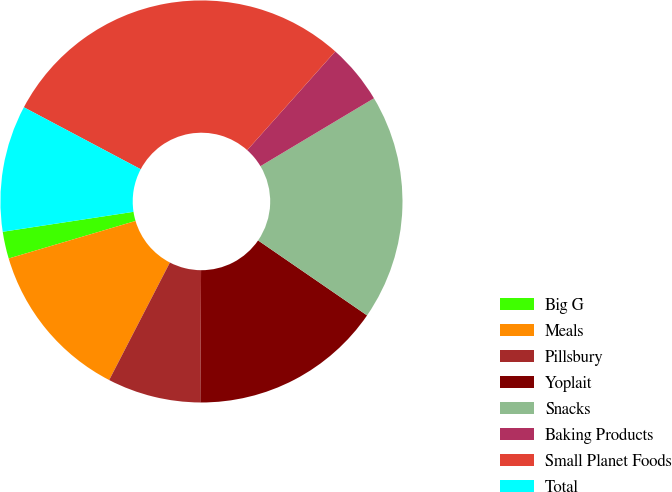Convert chart. <chart><loc_0><loc_0><loc_500><loc_500><pie_chart><fcel>Big G<fcel>Meals<fcel>Pillsbury<fcel>Yoplait<fcel>Snacks<fcel>Baking Products<fcel>Small Planet Foods<fcel>Total<nl><fcel>2.17%<fcel>12.83%<fcel>7.5%<fcel>15.5%<fcel>18.17%<fcel>4.83%<fcel>28.83%<fcel>10.17%<nl></chart> 